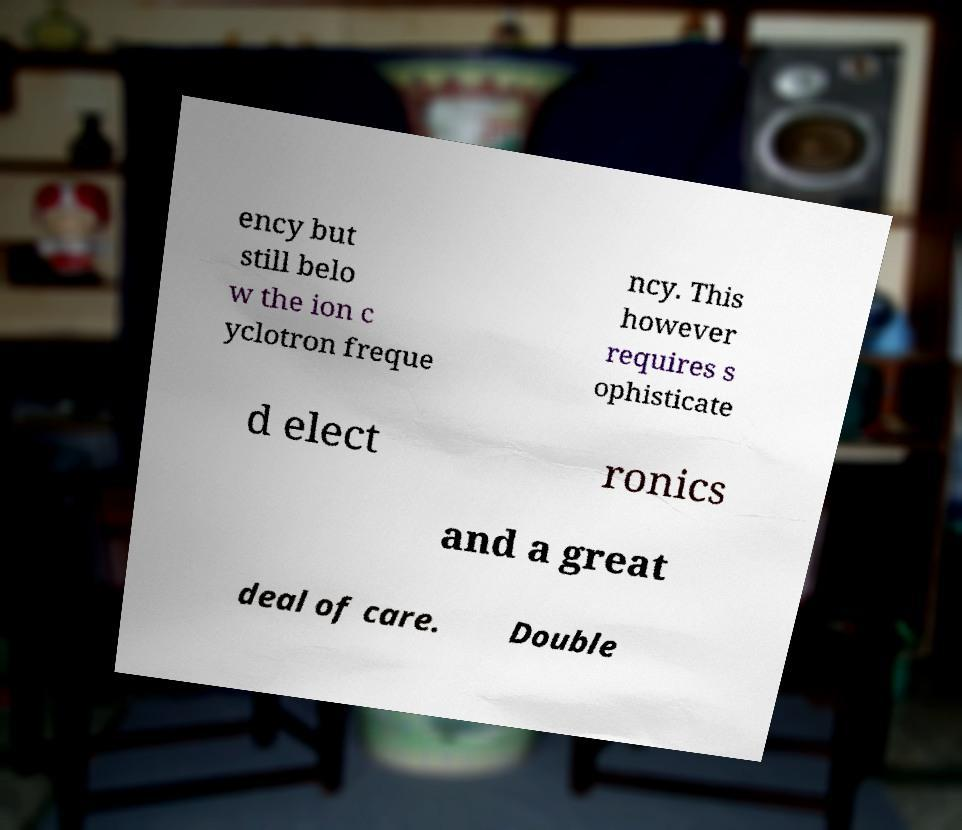Please read and relay the text visible in this image. What does it say? ency but still belo w the ion c yclotron freque ncy. This however requires s ophisticate d elect ronics and a great deal of care. Double 